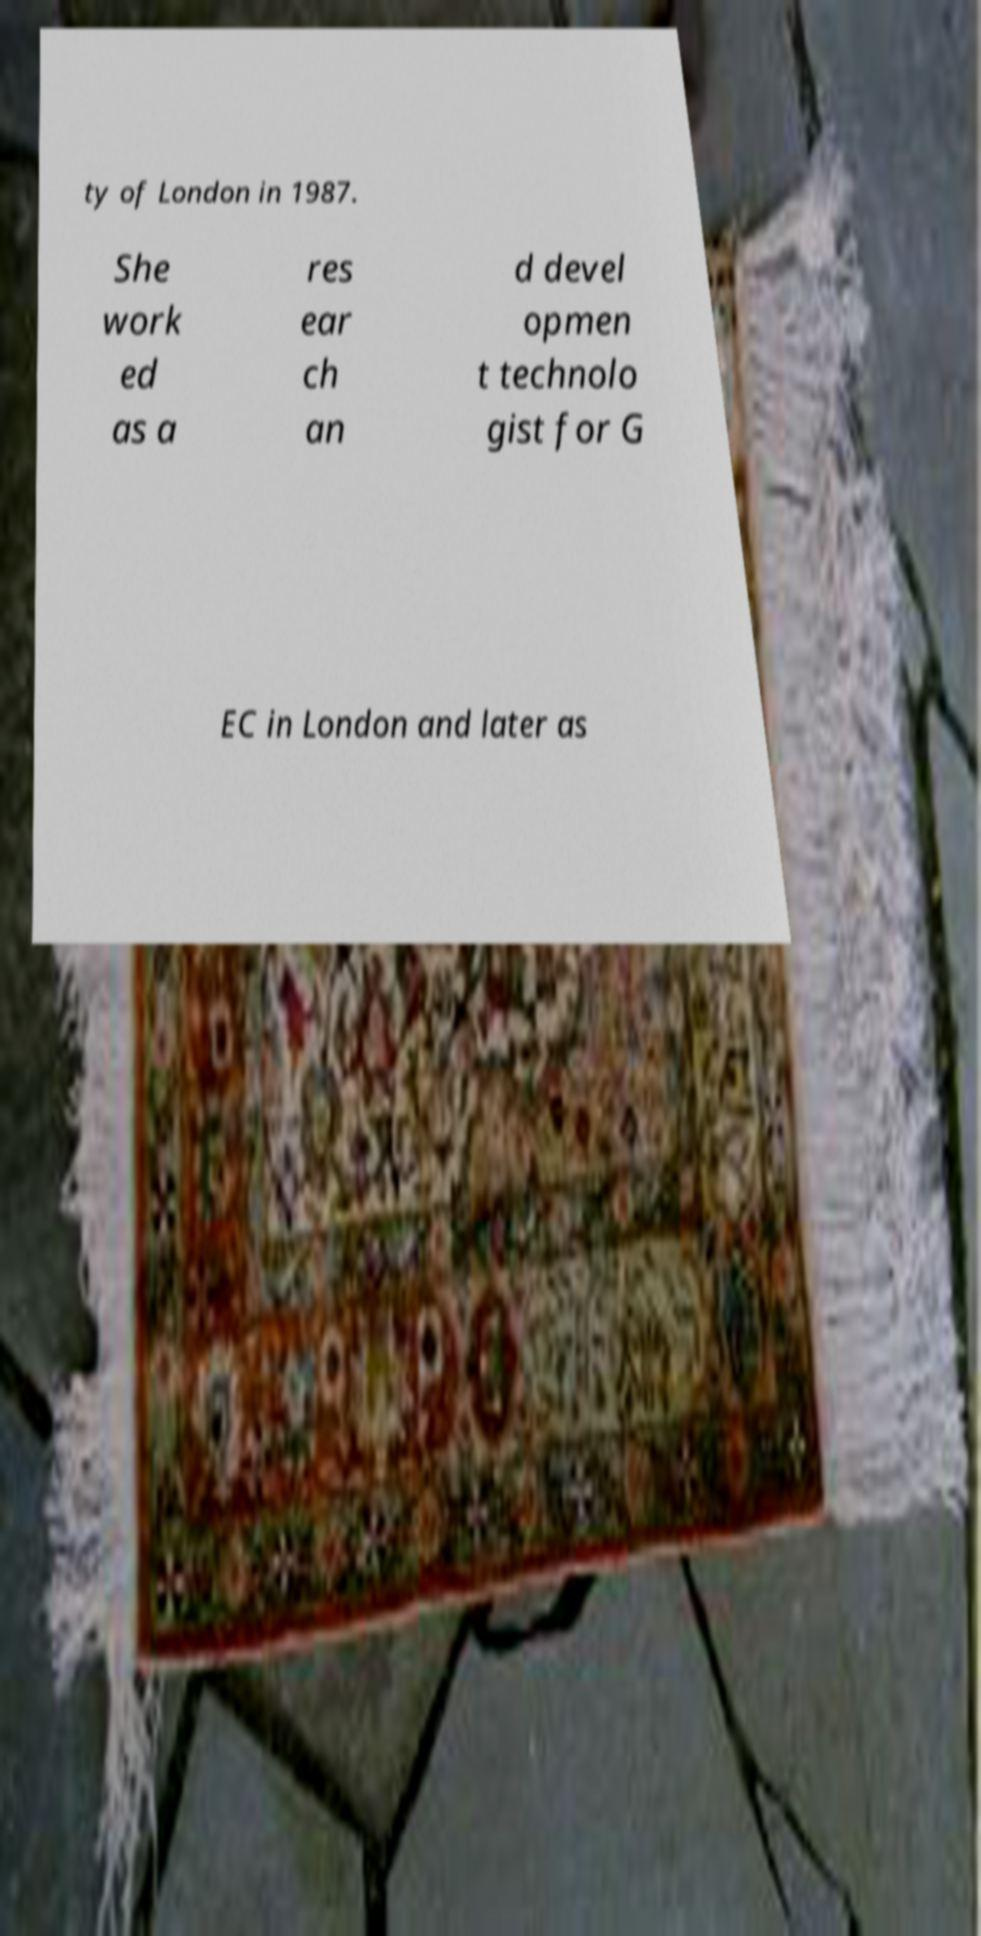Could you assist in decoding the text presented in this image and type it out clearly? ty of London in 1987. She work ed as a res ear ch an d devel opmen t technolo gist for G EC in London and later as 